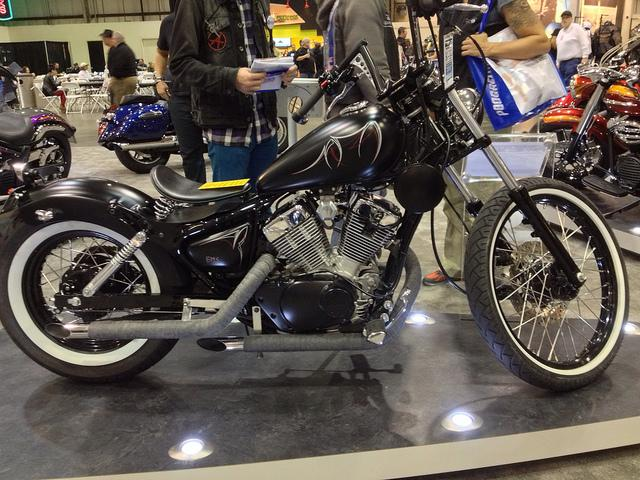What would you call the metal poles connecting to the front wheel?

Choices:
A) spoon
B) fork
C) knife
D) fender fork 